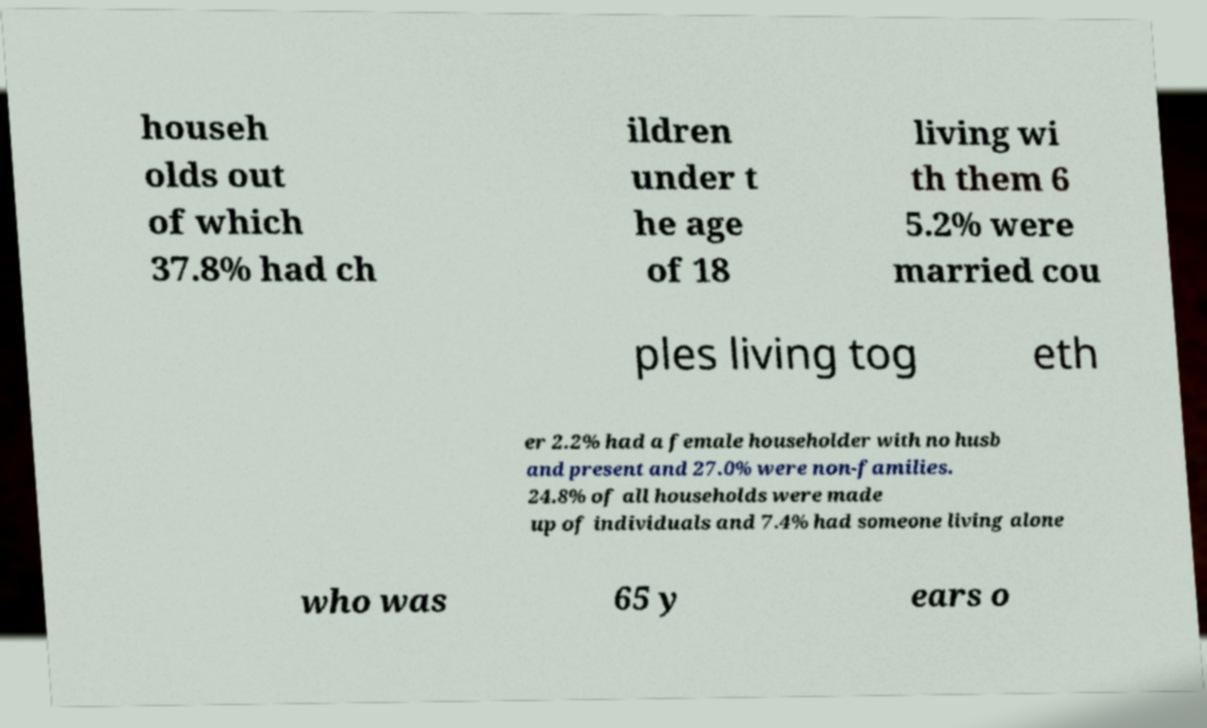Can you accurately transcribe the text from the provided image for me? househ olds out of which 37.8% had ch ildren under t he age of 18 living wi th them 6 5.2% were married cou ples living tog eth er 2.2% had a female householder with no husb and present and 27.0% were non-families. 24.8% of all households were made up of individuals and 7.4% had someone living alone who was 65 y ears o 